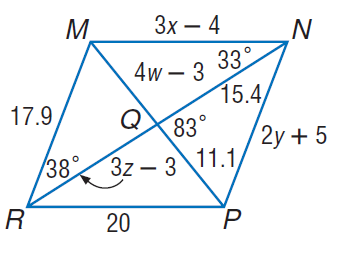Answer the mathemtical geometry problem and directly provide the correct option letter.
Question: Use parallelogram M N P R to find m \angle N R P.
Choices: A: 33 B: 38 C: 71 D: 109 A 